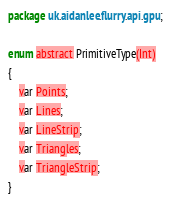Convert code to text. <code><loc_0><loc_0><loc_500><loc_500><_Haxe_>package uk.aidanlee.flurry.api.gpu;

enum abstract PrimitiveType(Int)
{
    var Points;
    var Lines;
    var LineStrip;
    var Triangles;
    var TriangleStrip;
}</code> 